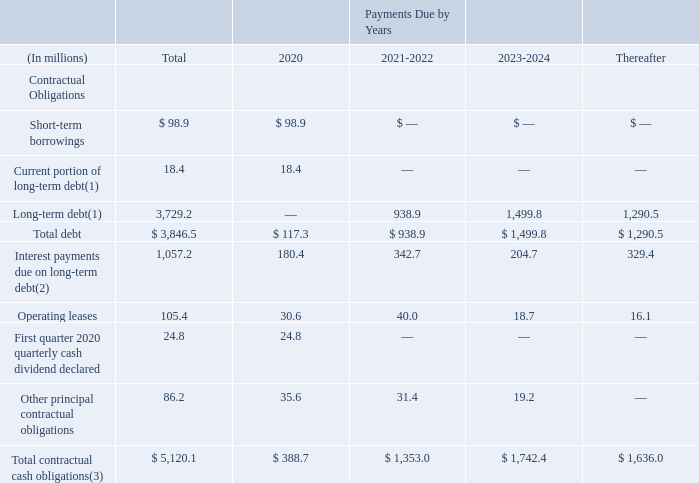The following table summarizes our principal contractual obligations and sets forth the amounts of required or contingently required cash outlays in 2020 and future years:
(1) Current portion of long-term debt is exclusive of present value discounting for finance lease obligations of $1.7 million. The long-term debt is exclusive of capitalized lender fees of $22.2 million, present value discounting for finance lease obligations of $6.1 million, and debt discounts of $2.3 million.
(2) Includes interest payments required under our senior notes issuances and Amended Credit Facility only. The interest payments included above for our Term Loan A were calculated using the following assumptions: • interest rates based on stated LIBOR rates as of December 31, 2019; and • all non-US Dollar balances are converted using exchange rates as of December 31, 2019.
(3) Obligations related to defined benefit pension plans and other post-employment benefit plans have been excluded from the table above, due to factors such as the retirement of employees, the performance of plan assets and economic and actuarial assumptions, as it is not reasonably possible to estimate when these obligations will become due. Refer to Note 17, “Profit Sharing, Retirement Savings Plans and Defined Benefit Pension Plans,” and Note 18, “Other Post- Employment Benefits and Other Employee Benefit Plans,” of the Notes to Consolidated Financial Statements for additional information related to these plans.
Short-term Borrowings, Current Portion of Long-Term Debt and Long-Term Debt
Short-term borrowings, current portion of long-term debt and long-term debt represent the principal amount of the debt
required to be repaid in each period.
Operating Leases
The contractual operating lease obligations listed in the table above represent estimated future minimum annual rental commitments primarily under non-cancelable real and personal property leases as of December 31, 2019.
Other Principal Contractual Obligations
Other principal contractual obligations include agreements to purchase an estimated amount of goods, including raw materials, or services, including energy, in the normal course of business. These obligations are enforceable and legally binding and specify all significant terms, including fixed or minimum quantities to be purchased, minimum or variable price provisions and the approximate timing of the purchase. The amounts included in the table above represent estimates of the minimum amounts we are obligated to pay, or reasonably likely to pay under these agreements. We may purchase additional goods or services above the minimum requirements of these obligations and, as a result use additional cash.
What does this table represent? Summarizes our principal contractual obligations and sets forth the amounts of required or contingently required cash outlays in 2020 and future years:. What is the total Total contractual cash obligations for all years?
Answer scale should be: million. 5,120.1. What assumptions were used to calculate interest payments for Term Loan A Interest rates based on stated libor rates as of december 31, 2019; and • all non-us dollar balances are converted using exchange rates as of december 31, 2019. What is the Total contractual cash obligations for years 2020-2024 inclusive?
Answer scale should be: million. 388.7+1,353.0+1,742.4
Answer: 3484.1. What is the Total contractual cash obligations for year 2020 expressed as a proportion of Total contractual cash obligations for all years? 388.7/5,120.1
Answer: 0.08. What is the percentage change of Operating lease from 2021-2022 to 2023-2024?
Answer scale should be: percent. (18.7-40.0)/40.0
Answer: -53.25. 